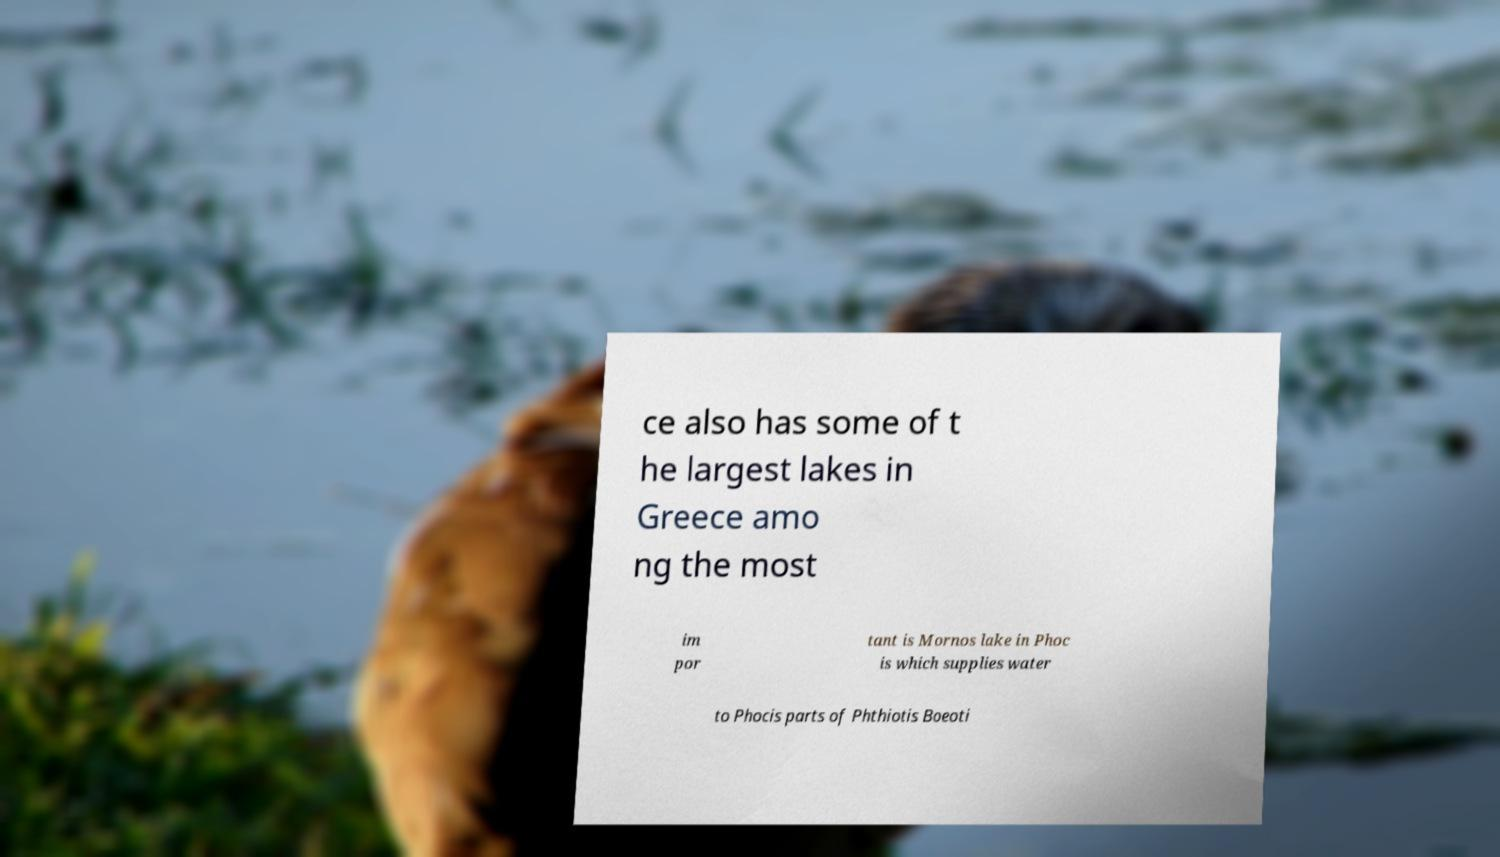For documentation purposes, I need the text within this image transcribed. Could you provide that? ce also has some of t he largest lakes in Greece amo ng the most im por tant is Mornos lake in Phoc is which supplies water to Phocis parts of Phthiotis Boeoti 